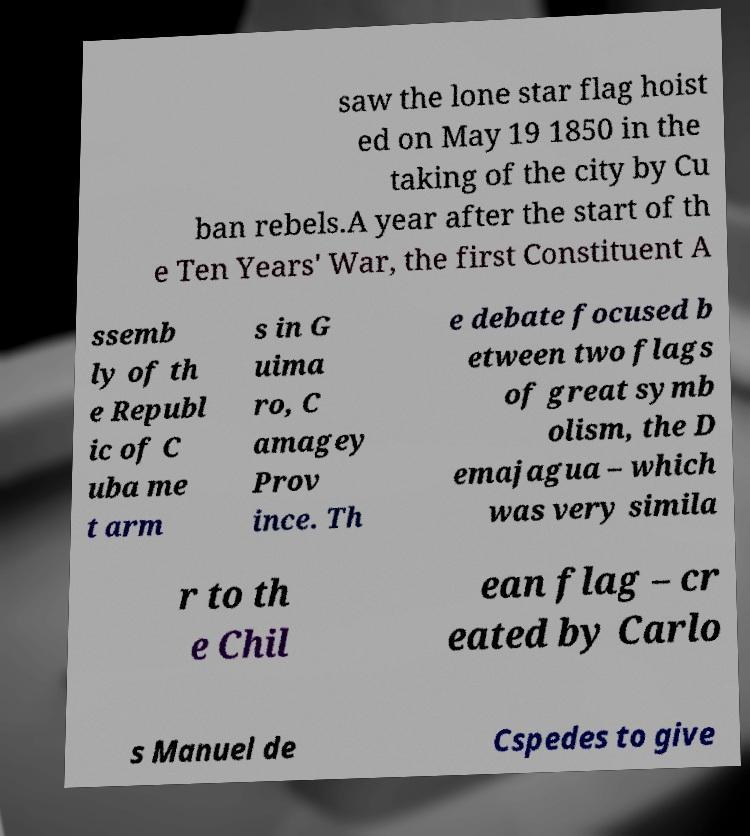Could you extract and type out the text from this image? saw the lone star flag hoist ed on May 19 1850 in the taking of the city by Cu ban rebels.A year after the start of th e Ten Years' War, the first Constituent A ssemb ly of th e Republ ic of C uba me t arm s in G uima ro, C amagey Prov ince. Th e debate focused b etween two flags of great symb olism, the D emajagua – which was very simila r to th e Chil ean flag – cr eated by Carlo s Manuel de Cspedes to give 